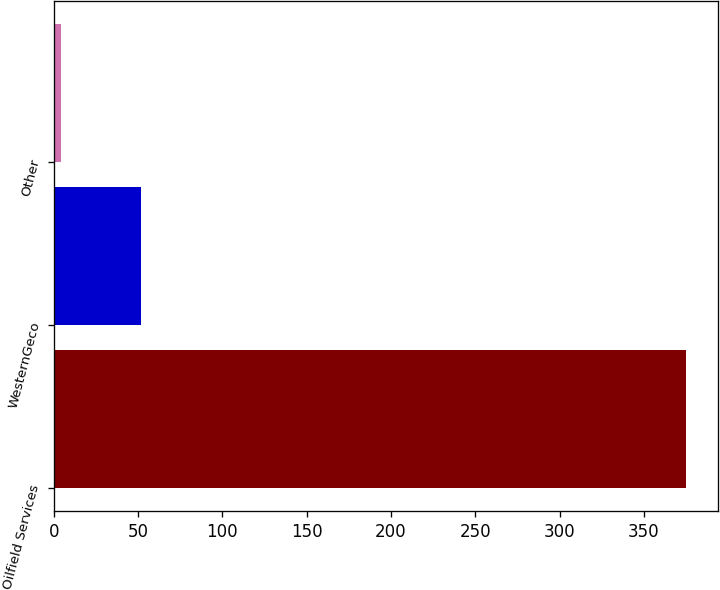Convert chart to OTSL. <chart><loc_0><loc_0><loc_500><loc_500><bar_chart><fcel>Oilfield Services<fcel>WesternGeco<fcel>Other<nl><fcel>375<fcel>52<fcel>4<nl></chart> 